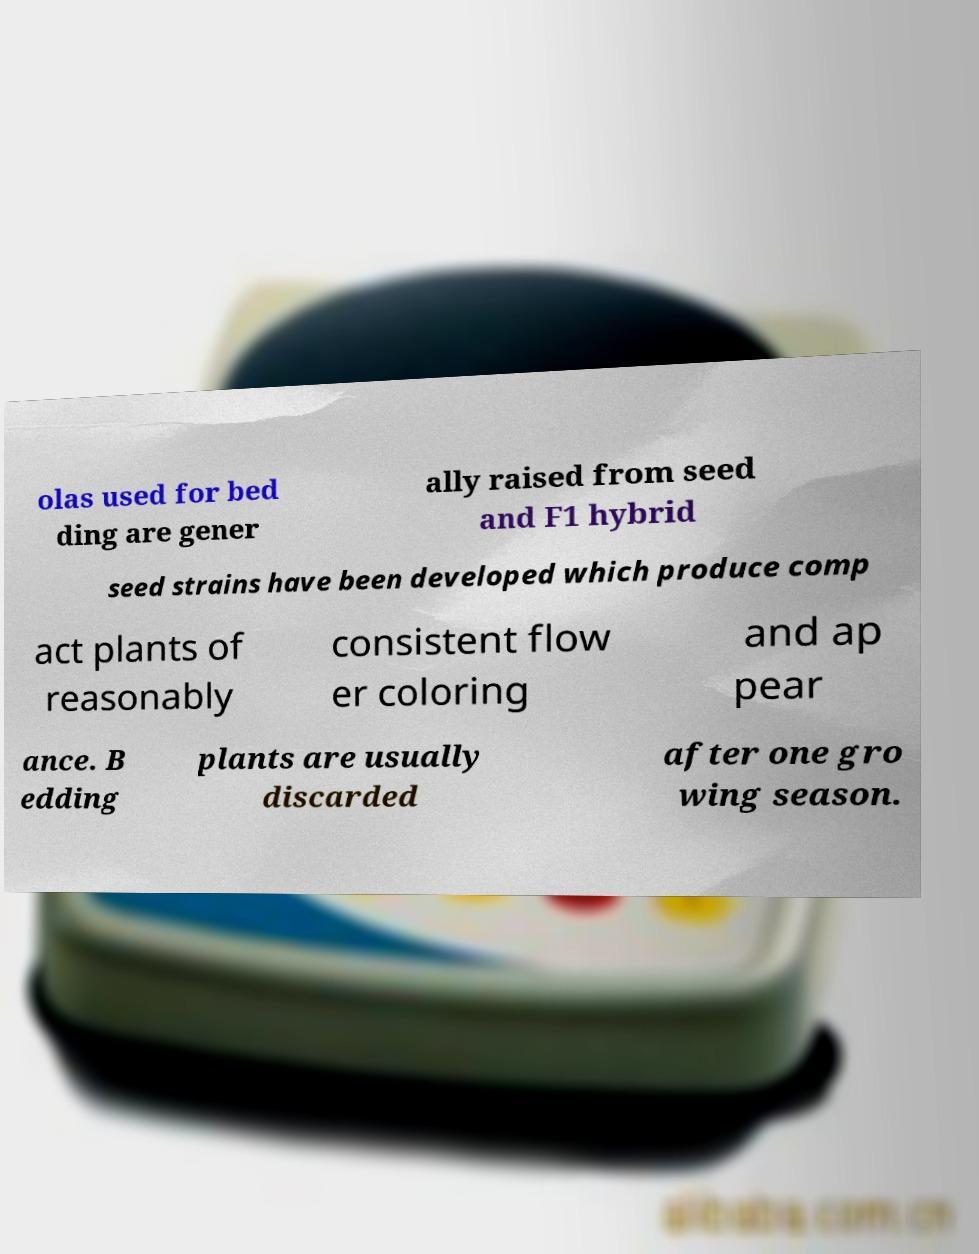Can you read and provide the text displayed in the image?This photo seems to have some interesting text. Can you extract and type it out for me? olas used for bed ding are gener ally raised from seed and F1 hybrid seed strains have been developed which produce comp act plants of reasonably consistent flow er coloring and ap pear ance. B edding plants are usually discarded after one gro wing season. 